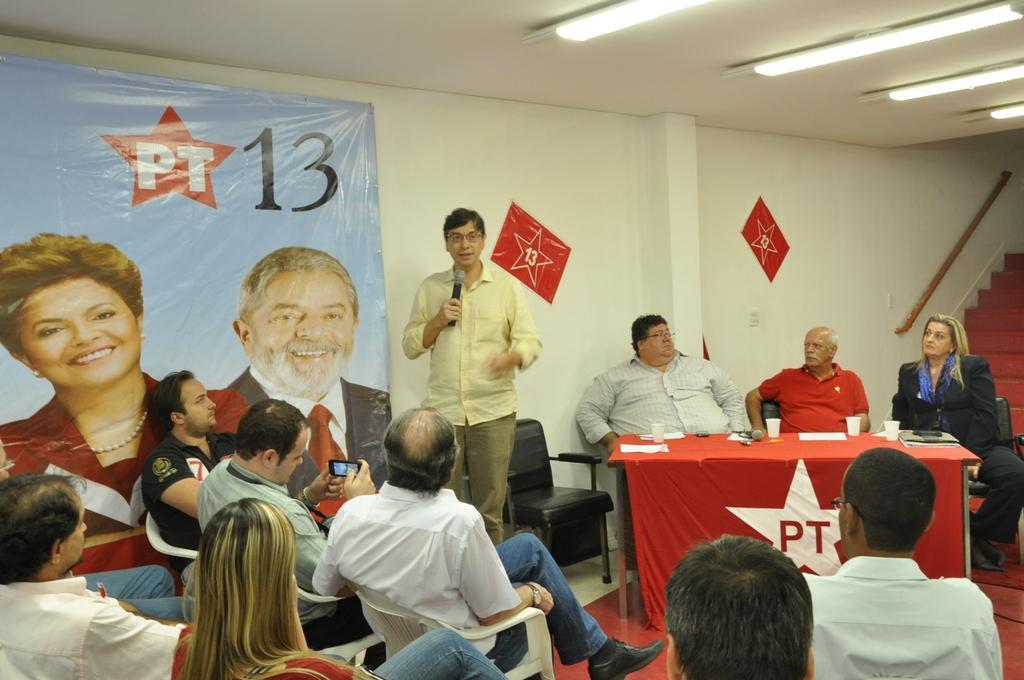Could you give a brief overview of what you see in this image? In this image we can see these people are sitting on the chairs and this person is standing while holding mic in his hands. Here we can see these people are sitting on the chairs near the table where glasses, papers and mic are kept. In the background, we can see the banners, stairs and lights to the ceiling. 